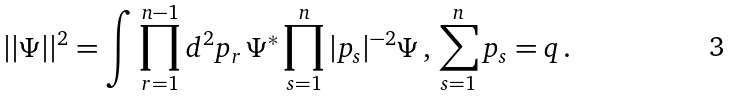<formula> <loc_0><loc_0><loc_500><loc_500>| | \Psi | | ^ { 2 } = \int \prod _ { r = 1 } ^ { n - 1 } d ^ { 2 } p _ { r } \, \Psi ^ { * } \prod _ { s = 1 } ^ { n } | p _ { s } | ^ { - 2 } \Psi \, , \, \sum _ { s = 1 } ^ { n } p _ { s } = q \, .</formula> 